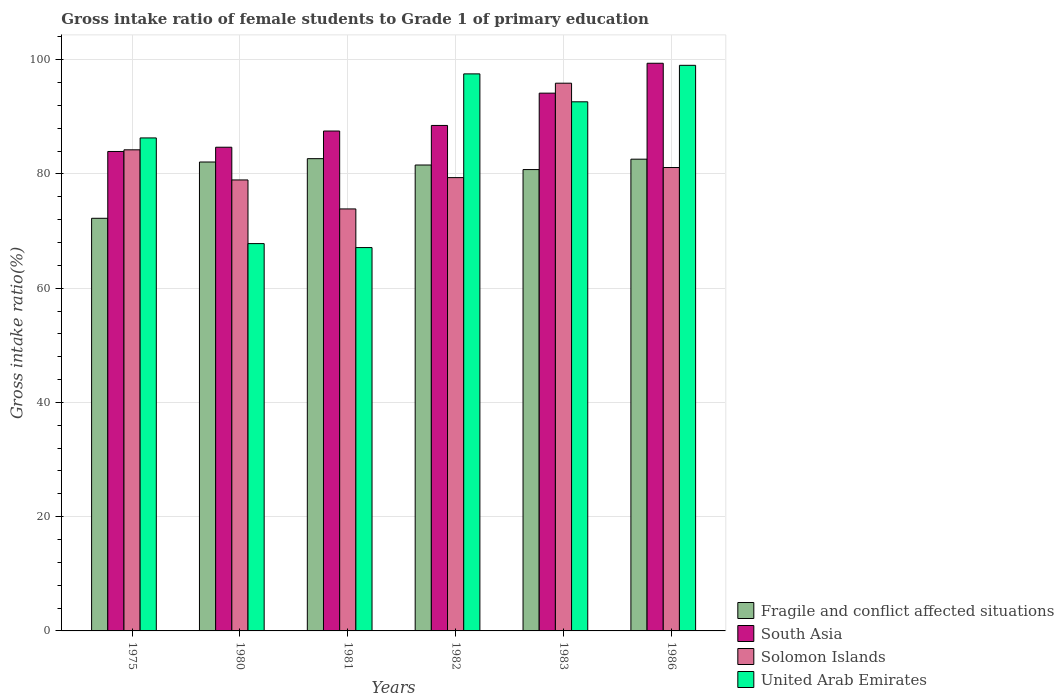How many different coloured bars are there?
Ensure brevity in your answer.  4. How many groups of bars are there?
Give a very brief answer. 6. Are the number of bars on each tick of the X-axis equal?
Ensure brevity in your answer.  Yes. How many bars are there on the 6th tick from the right?
Make the answer very short. 4. What is the gross intake ratio in Solomon Islands in 1986?
Your response must be concise. 81.12. Across all years, what is the maximum gross intake ratio in United Arab Emirates?
Your response must be concise. 99.01. Across all years, what is the minimum gross intake ratio in Fragile and conflict affected situations?
Make the answer very short. 72.23. In which year was the gross intake ratio in Fragile and conflict affected situations maximum?
Offer a terse response. 1981. In which year was the gross intake ratio in Fragile and conflict affected situations minimum?
Your answer should be very brief. 1975. What is the total gross intake ratio in Solomon Islands in the graph?
Make the answer very short. 493.39. What is the difference between the gross intake ratio in United Arab Emirates in 1975 and that in 1982?
Ensure brevity in your answer.  -11.21. What is the difference between the gross intake ratio in Solomon Islands in 1975 and the gross intake ratio in South Asia in 1980?
Provide a succinct answer. -0.45. What is the average gross intake ratio in Fragile and conflict affected situations per year?
Provide a short and direct response. 80.32. In the year 1981, what is the difference between the gross intake ratio in South Asia and gross intake ratio in Fragile and conflict affected situations?
Make the answer very short. 4.84. In how many years, is the gross intake ratio in South Asia greater than 72 %?
Your answer should be compact. 6. What is the ratio of the gross intake ratio in United Arab Emirates in 1982 to that in 1983?
Offer a terse response. 1.05. Is the gross intake ratio in Fragile and conflict affected situations in 1975 less than that in 1986?
Make the answer very short. Yes. What is the difference between the highest and the second highest gross intake ratio in Solomon Islands?
Offer a terse response. 11.66. What is the difference between the highest and the lowest gross intake ratio in Fragile and conflict affected situations?
Your response must be concise. 10.44. In how many years, is the gross intake ratio in South Asia greater than the average gross intake ratio in South Asia taken over all years?
Give a very brief answer. 2. What does the 2nd bar from the left in 1981 represents?
Keep it short and to the point. South Asia. What does the 2nd bar from the right in 1981 represents?
Provide a short and direct response. Solomon Islands. How many bars are there?
Your response must be concise. 24. How many years are there in the graph?
Provide a succinct answer. 6. What is the difference between two consecutive major ticks on the Y-axis?
Your answer should be very brief. 20. Are the values on the major ticks of Y-axis written in scientific E-notation?
Make the answer very short. No. Does the graph contain grids?
Your answer should be very brief. Yes. How many legend labels are there?
Ensure brevity in your answer.  4. How are the legend labels stacked?
Provide a short and direct response. Vertical. What is the title of the graph?
Your answer should be compact. Gross intake ratio of female students to Grade 1 of primary education. What is the label or title of the X-axis?
Your response must be concise. Years. What is the label or title of the Y-axis?
Your response must be concise. Gross intake ratio(%). What is the Gross intake ratio(%) of Fragile and conflict affected situations in 1975?
Your answer should be very brief. 72.23. What is the Gross intake ratio(%) in South Asia in 1975?
Ensure brevity in your answer.  83.93. What is the Gross intake ratio(%) in Solomon Islands in 1975?
Give a very brief answer. 84.22. What is the Gross intake ratio(%) of United Arab Emirates in 1975?
Offer a very short reply. 86.3. What is the Gross intake ratio(%) in Fragile and conflict affected situations in 1980?
Offer a terse response. 82.09. What is the Gross intake ratio(%) in South Asia in 1980?
Make the answer very short. 84.67. What is the Gross intake ratio(%) in Solomon Islands in 1980?
Ensure brevity in your answer.  78.95. What is the Gross intake ratio(%) in United Arab Emirates in 1980?
Provide a short and direct response. 67.8. What is the Gross intake ratio(%) of Fragile and conflict affected situations in 1981?
Ensure brevity in your answer.  82.67. What is the Gross intake ratio(%) in South Asia in 1981?
Ensure brevity in your answer.  87.51. What is the Gross intake ratio(%) in Solomon Islands in 1981?
Your answer should be compact. 73.87. What is the Gross intake ratio(%) of United Arab Emirates in 1981?
Ensure brevity in your answer.  67.11. What is the Gross intake ratio(%) of Fragile and conflict affected situations in 1982?
Your answer should be compact. 81.56. What is the Gross intake ratio(%) in South Asia in 1982?
Give a very brief answer. 88.49. What is the Gross intake ratio(%) of Solomon Islands in 1982?
Give a very brief answer. 79.35. What is the Gross intake ratio(%) of United Arab Emirates in 1982?
Offer a very short reply. 97.51. What is the Gross intake ratio(%) in Fragile and conflict affected situations in 1983?
Your response must be concise. 80.76. What is the Gross intake ratio(%) in South Asia in 1983?
Provide a short and direct response. 94.14. What is the Gross intake ratio(%) in Solomon Islands in 1983?
Make the answer very short. 95.88. What is the Gross intake ratio(%) of United Arab Emirates in 1983?
Your answer should be very brief. 92.62. What is the Gross intake ratio(%) in Fragile and conflict affected situations in 1986?
Offer a terse response. 82.58. What is the Gross intake ratio(%) in South Asia in 1986?
Offer a terse response. 99.37. What is the Gross intake ratio(%) in Solomon Islands in 1986?
Offer a very short reply. 81.12. What is the Gross intake ratio(%) in United Arab Emirates in 1986?
Your answer should be compact. 99.01. Across all years, what is the maximum Gross intake ratio(%) in Fragile and conflict affected situations?
Your answer should be compact. 82.67. Across all years, what is the maximum Gross intake ratio(%) of South Asia?
Your response must be concise. 99.37. Across all years, what is the maximum Gross intake ratio(%) in Solomon Islands?
Provide a succinct answer. 95.88. Across all years, what is the maximum Gross intake ratio(%) in United Arab Emirates?
Give a very brief answer. 99.01. Across all years, what is the minimum Gross intake ratio(%) of Fragile and conflict affected situations?
Your response must be concise. 72.23. Across all years, what is the minimum Gross intake ratio(%) in South Asia?
Provide a succinct answer. 83.93. Across all years, what is the minimum Gross intake ratio(%) of Solomon Islands?
Make the answer very short. 73.87. Across all years, what is the minimum Gross intake ratio(%) in United Arab Emirates?
Make the answer very short. 67.11. What is the total Gross intake ratio(%) of Fragile and conflict affected situations in the graph?
Offer a terse response. 481.89. What is the total Gross intake ratio(%) of South Asia in the graph?
Keep it short and to the point. 538.11. What is the total Gross intake ratio(%) in Solomon Islands in the graph?
Your answer should be compact. 493.39. What is the total Gross intake ratio(%) of United Arab Emirates in the graph?
Provide a short and direct response. 510.36. What is the difference between the Gross intake ratio(%) in Fragile and conflict affected situations in 1975 and that in 1980?
Offer a very short reply. -9.85. What is the difference between the Gross intake ratio(%) in South Asia in 1975 and that in 1980?
Provide a succinct answer. -0.74. What is the difference between the Gross intake ratio(%) of Solomon Islands in 1975 and that in 1980?
Provide a succinct answer. 5.27. What is the difference between the Gross intake ratio(%) in United Arab Emirates in 1975 and that in 1980?
Provide a short and direct response. 18.5. What is the difference between the Gross intake ratio(%) of Fragile and conflict affected situations in 1975 and that in 1981?
Provide a short and direct response. -10.44. What is the difference between the Gross intake ratio(%) of South Asia in 1975 and that in 1981?
Provide a short and direct response. -3.58. What is the difference between the Gross intake ratio(%) of Solomon Islands in 1975 and that in 1981?
Your answer should be very brief. 10.35. What is the difference between the Gross intake ratio(%) of United Arab Emirates in 1975 and that in 1981?
Your response must be concise. 19.19. What is the difference between the Gross intake ratio(%) in Fragile and conflict affected situations in 1975 and that in 1982?
Offer a terse response. -9.33. What is the difference between the Gross intake ratio(%) of South Asia in 1975 and that in 1982?
Provide a succinct answer. -4.56. What is the difference between the Gross intake ratio(%) in Solomon Islands in 1975 and that in 1982?
Keep it short and to the point. 4.87. What is the difference between the Gross intake ratio(%) in United Arab Emirates in 1975 and that in 1982?
Provide a short and direct response. -11.21. What is the difference between the Gross intake ratio(%) of Fragile and conflict affected situations in 1975 and that in 1983?
Offer a very short reply. -8.53. What is the difference between the Gross intake ratio(%) in South Asia in 1975 and that in 1983?
Make the answer very short. -10.21. What is the difference between the Gross intake ratio(%) of Solomon Islands in 1975 and that in 1983?
Give a very brief answer. -11.66. What is the difference between the Gross intake ratio(%) of United Arab Emirates in 1975 and that in 1983?
Give a very brief answer. -6.32. What is the difference between the Gross intake ratio(%) of Fragile and conflict affected situations in 1975 and that in 1986?
Ensure brevity in your answer.  -10.35. What is the difference between the Gross intake ratio(%) in South Asia in 1975 and that in 1986?
Make the answer very short. -15.44. What is the difference between the Gross intake ratio(%) of Solomon Islands in 1975 and that in 1986?
Your answer should be very brief. 3.1. What is the difference between the Gross intake ratio(%) of United Arab Emirates in 1975 and that in 1986?
Offer a terse response. -12.71. What is the difference between the Gross intake ratio(%) in Fragile and conflict affected situations in 1980 and that in 1981?
Your answer should be very brief. -0.58. What is the difference between the Gross intake ratio(%) of South Asia in 1980 and that in 1981?
Your response must be concise. -2.84. What is the difference between the Gross intake ratio(%) in Solomon Islands in 1980 and that in 1981?
Make the answer very short. 5.07. What is the difference between the Gross intake ratio(%) of United Arab Emirates in 1980 and that in 1981?
Your answer should be very brief. 0.69. What is the difference between the Gross intake ratio(%) of Fragile and conflict affected situations in 1980 and that in 1982?
Make the answer very short. 0.53. What is the difference between the Gross intake ratio(%) of South Asia in 1980 and that in 1982?
Keep it short and to the point. -3.81. What is the difference between the Gross intake ratio(%) of Solomon Islands in 1980 and that in 1982?
Offer a terse response. -0.41. What is the difference between the Gross intake ratio(%) of United Arab Emirates in 1980 and that in 1982?
Give a very brief answer. -29.71. What is the difference between the Gross intake ratio(%) in Fragile and conflict affected situations in 1980 and that in 1983?
Your answer should be very brief. 1.33. What is the difference between the Gross intake ratio(%) in South Asia in 1980 and that in 1983?
Offer a very short reply. -9.47. What is the difference between the Gross intake ratio(%) in Solomon Islands in 1980 and that in 1983?
Make the answer very short. -16.94. What is the difference between the Gross intake ratio(%) in United Arab Emirates in 1980 and that in 1983?
Give a very brief answer. -24.82. What is the difference between the Gross intake ratio(%) of Fragile and conflict affected situations in 1980 and that in 1986?
Keep it short and to the point. -0.49. What is the difference between the Gross intake ratio(%) in South Asia in 1980 and that in 1986?
Provide a succinct answer. -14.7. What is the difference between the Gross intake ratio(%) in Solomon Islands in 1980 and that in 1986?
Ensure brevity in your answer.  -2.17. What is the difference between the Gross intake ratio(%) of United Arab Emirates in 1980 and that in 1986?
Ensure brevity in your answer.  -31.21. What is the difference between the Gross intake ratio(%) in Fragile and conflict affected situations in 1981 and that in 1982?
Make the answer very short. 1.11. What is the difference between the Gross intake ratio(%) in South Asia in 1981 and that in 1982?
Offer a very short reply. -0.98. What is the difference between the Gross intake ratio(%) in Solomon Islands in 1981 and that in 1982?
Offer a very short reply. -5.48. What is the difference between the Gross intake ratio(%) in United Arab Emirates in 1981 and that in 1982?
Provide a short and direct response. -30.41. What is the difference between the Gross intake ratio(%) of Fragile and conflict affected situations in 1981 and that in 1983?
Offer a very short reply. 1.91. What is the difference between the Gross intake ratio(%) in South Asia in 1981 and that in 1983?
Your answer should be very brief. -6.63. What is the difference between the Gross intake ratio(%) in Solomon Islands in 1981 and that in 1983?
Your response must be concise. -22.01. What is the difference between the Gross intake ratio(%) of United Arab Emirates in 1981 and that in 1983?
Offer a very short reply. -25.52. What is the difference between the Gross intake ratio(%) in Fragile and conflict affected situations in 1981 and that in 1986?
Make the answer very short. 0.09. What is the difference between the Gross intake ratio(%) of South Asia in 1981 and that in 1986?
Keep it short and to the point. -11.86. What is the difference between the Gross intake ratio(%) of Solomon Islands in 1981 and that in 1986?
Your response must be concise. -7.25. What is the difference between the Gross intake ratio(%) in United Arab Emirates in 1981 and that in 1986?
Offer a very short reply. -31.9. What is the difference between the Gross intake ratio(%) in Fragile and conflict affected situations in 1982 and that in 1983?
Ensure brevity in your answer.  0.8. What is the difference between the Gross intake ratio(%) of South Asia in 1982 and that in 1983?
Ensure brevity in your answer.  -5.65. What is the difference between the Gross intake ratio(%) of Solomon Islands in 1982 and that in 1983?
Provide a succinct answer. -16.53. What is the difference between the Gross intake ratio(%) in United Arab Emirates in 1982 and that in 1983?
Ensure brevity in your answer.  4.89. What is the difference between the Gross intake ratio(%) in Fragile and conflict affected situations in 1982 and that in 1986?
Provide a succinct answer. -1.02. What is the difference between the Gross intake ratio(%) in South Asia in 1982 and that in 1986?
Provide a short and direct response. -10.89. What is the difference between the Gross intake ratio(%) in Solomon Islands in 1982 and that in 1986?
Offer a terse response. -1.77. What is the difference between the Gross intake ratio(%) in United Arab Emirates in 1982 and that in 1986?
Make the answer very short. -1.5. What is the difference between the Gross intake ratio(%) of Fragile and conflict affected situations in 1983 and that in 1986?
Keep it short and to the point. -1.82. What is the difference between the Gross intake ratio(%) in South Asia in 1983 and that in 1986?
Offer a very short reply. -5.23. What is the difference between the Gross intake ratio(%) in Solomon Islands in 1983 and that in 1986?
Make the answer very short. 14.76. What is the difference between the Gross intake ratio(%) in United Arab Emirates in 1983 and that in 1986?
Offer a terse response. -6.39. What is the difference between the Gross intake ratio(%) of Fragile and conflict affected situations in 1975 and the Gross intake ratio(%) of South Asia in 1980?
Offer a terse response. -12.44. What is the difference between the Gross intake ratio(%) in Fragile and conflict affected situations in 1975 and the Gross intake ratio(%) in Solomon Islands in 1980?
Your response must be concise. -6.71. What is the difference between the Gross intake ratio(%) in Fragile and conflict affected situations in 1975 and the Gross intake ratio(%) in United Arab Emirates in 1980?
Ensure brevity in your answer.  4.43. What is the difference between the Gross intake ratio(%) in South Asia in 1975 and the Gross intake ratio(%) in Solomon Islands in 1980?
Ensure brevity in your answer.  4.98. What is the difference between the Gross intake ratio(%) of South Asia in 1975 and the Gross intake ratio(%) of United Arab Emirates in 1980?
Ensure brevity in your answer.  16.13. What is the difference between the Gross intake ratio(%) in Solomon Islands in 1975 and the Gross intake ratio(%) in United Arab Emirates in 1980?
Ensure brevity in your answer.  16.42. What is the difference between the Gross intake ratio(%) of Fragile and conflict affected situations in 1975 and the Gross intake ratio(%) of South Asia in 1981?
Provide a short and direct response. -15.28. What is the difference between the Gross intake ratio(%) of Fragile and conflict affected situations in 1975 and the Gross intake ratio(%) of Solomon Islands in 1981?
Your response must be concise. -1.64. What is the difference between the Gross intake ratio(%) in Fragile and conflict affected situations in 1975 and the Gross intake ratio(%) in United Arab Emirates in 1981?
Your answer should be compact. 5.12. What is the difference between the Gross intake ratio(%) of South Asia in 1975 and the Gross intake ratio(%) of Solomon Islands in 1981?
Give a very brief answer. 10.06. What is the difference between the Gross intake ratio(%) in South Asia in 1975 and the Gross intake ratio(%) in United Arab Emirates in 1981?
Provide a short and direct response. 16.82. What is the difference between the Gross intake ratio(%) in Solomon Islands in 1975 and the Gross intake ratio(%) in United Arab Emirates in 1981?
Provide a short and direct response. 17.11. What is the difference between the Gross intake ratio(%) of Fragile and conflict affected situations in 1975 and the Gross intake ratio(%) of South Asia in 1982?
Make the answer very short. -16.25. What is the difference between the Gross intake ratio(%) in Fragile and conflict affected situations in 1975 and the Gross intake ratio(%) in Solomon Islands in 1982?
Your response must be concise. -7.12. What is the difference between the Gross intake ratio(%) of Fragile and conflict affected situations in 1975 and the Gross intake ratio(%) of United Arab Emirates in 1982?
Offer a terse response. -25.28. What is the difference between the Gross intake ratio(%) of South Asia in 1975 and the Gross intake ratio(%) of Solomon Islands in 1982?
Give a very brief answer. 4.58. What is the difference between the Gross intake ratio(%) of South Asia in 1975 and the Gross intake ratio(%) of United Arab Emirates in 1982?
Provide a short and direct response. -13.58. What is the difference between the Gross intake ratio(%) of Solomon Islands in 1975 and the Gross intake ratio(%) of United Arab Emirates in 1982?
Offer a terse response. -13.3. What is the difference between the Gross intake ratio(%) of Fragile and conflict affected situations in 1975 and the Gross intake ratio(%) of South Asia in 1983?
Provide a short and direct response. -21.91. What is the difference between the Gross intake ratio(%) of Fragile and conflict affected situations in 1975 and the Gross intake ratio(%) of Solomon Islands in 1983?
Your answer should be compact. -23.65. What is the difference between the Gross intake ratio(%) in Fragile and conflict affected situations in 1975 and the Gross intake ratio(%) in United Arab Emirates in 1983?
Make the answer very short. -20.39. What is the difference between the Gross intake ratio(%) of South Asia in 1975 and the Gross intake ratio(%) of Solomon Islands in 1983?
Give a very brief answer. -11.95. What is the difference between the Gross intake ratio(%) of South Asia in 1975 and the Gross intake ratio(%) of United Arab Emirates in 1983?
Keep it short and to the point. -8.69. What is the difference between the Gross intake ratio(%) of Solomon Islands in 1975 and the Gross intake ratio(%) of United Arab Emirates in 1983?
Offer a terse response. -8.41. What is the difference between the Gross intake ratio(%) in Fragile and conflict affected situations in 1975 and the Gross intake ratio(%) in South Asia in 1986?
Ensure brevity in your answer.  -27.14. What is the difference between the Gross intake ratio(%) in Fragile and conflict affected situations in 1975 and the Gross intake ratio(%) in Solomon Islands in 1986?
Offer a terse response. -8.89. What is the difference between the Gross intake ratio(%) of Fragile and conflict affected situations in 1975 and the Gross intake ratio(%) of United Arab Emirates in 1986?
Ensure brevity in your answer.  -26.78. What is the difference between the Gross intake ratio(%) in South Asia in 1975 and the Gross intake ratio(%) in Solomon Islands in 1986?
Offer a terse response. 2.81. What is the difference between the Gross intake ratio(%) in South Asia in 1975 and the Gross intake ratio(%) in United Arab Emirates in 1986?
Your answer should be compact. -15.08. What is the difference between the Gross intake ratio(%) in Solomon Islands in 1975 and the Gross intake ratio(%) in United Arab Emirates in 1986?
Your response must be concise. -14.79. What is the difference between the Gross intake ratio(%) in Fragile and conflict affected situations in 1980 and the Gross intake ratio(%) in South Asia in 1981?
Ensure brevity in your answer.  -5.42. What is the difference between the Gross intake ratio(%) in Fragile and conflict affected situations in 1980 and the Gross intake ratio(%) in Solomon Islands in 1981?
Offer a very short reply. 8.21. What is the difference between the Gross intake ratio(%) in Fragile and conflict affected situations in 1980 and the Gross intake ratio(%) in United Arab Emirates in 1981?
Keep it short and to the point. 14.98. What is the difference between the Gross intake ratio(%) in South Asia in 1980 and the Gross intake ratio(%) in Solomon Islands in 1981?
Provide a short and direct response. 10.8. What is the difference between the Gross intake ratio(%) of South Asia in 1980 and the Gross intake ratio(%) of United Arab Emirates in 1981?
Give a very brief answer. 17.56. What is the difference between the Gross intake ratio(%) in Solomon Islands in 1980 and the Gross intake ratio(%) in United Arab Emirates in 1981?
Your response must be concise. 11.84. What is the difference between the Gross intake ratio(%) in Fragile and conflict affected situations in 1980 and the Gross intake ratio(%) in Solomon Islands in 1982?
Give a very brief answer. 2.73. What is the difference between the Gross intake ratio(%) of Fragile and conflict affected situations in 1980 and the Gross intake ratio(%) of United Arab Emirates in 1982?
Provide a short and direct response. -15.43. What is the difference between the Gross intake ratio(%) in South Asia in 1980 and the Gross intake ratio(%) in Solomon Islands in 1982?
Offer a terse response. 5.32. What is the difference between the Gross intake ratio(%) of South Asia in 1980 and the Gross intake ratio(%) of United Arab Emirates in 1982?
Your answer should be very brief. -12.84. What is the difference between the Gross intake ratio(%) in Solomon Islands in 1980 and the Gross intake ratio(%) in United Arab Emirates in 1982?
Your answer should be compact. -18.57. What is the difference between the Gross intake ratio(%) in Fragile and conflict affected situations in 1980 and the Gross intake ratio(%) in South Asia in 1983?
Ensure brevity in your answer.  -12.05. What is the difference between the Gross intake ratio(%) of Fragile and conflict affected situations in 1980 and the Gross intake ratio(%) of Solomon Islands in 1983?
Offer a very short reply. -13.8. What is the difference between the Gross intake ratio(%) of Fragile and conflict affected situations in 1980 and the Gross intake ratio(%) of United Arab Emirates in 1983?
Your answer should be very brief. -10.54. What is the difference between the Gross intake ratio(%) of South Asia in 1980 and the Gross intake ratio(%) of Solomon Islands in 1983?
Keep it short and to the point. -11.21. What is the difference between the Gross intake ratio(%) of South Asia in 1980 and the Gross intake ratio(%) of United Arab Emirates in 1983?
Your answer should be very brief. -7.95. What is the difference between the Gross intake ratio(%) of Solomon Islands in 1980 and the Gross intake ratio(%) of United Arab Emirates in 1983?
Ensure brevity in your answer.  -13.68. What is the difference between the Gross intake ratio(%) of Fragile and conflict affected situations in 1980 and the Gross intake ratio(%) of South Asia in 1986?
Provide a short and direct response. -17.29. What is the difference between the Gross intake ratio(%) of Fragile and conflict affected situations in 1980 and the Gross intake ratio(%) of Solomon Islands in 1986?
Provide a succinct answer. 0.97. What is the difference between the Gross intake ratio(%) of Fragile and conflict affected situations in 1980 and the Gross intake ratio(%) of United Arab Emirates in 1986?
Offer a very short reply. -16.92. What is the difference between the Gross intake ratio(%) in South Asia in 1980 and the Gross intake ratio(%) in Solomon Islands in 1986?
Make the answer very short. 3.55. What is the difference between the Gross intake ratio(%) in South Asia in 1980 and the Gross intake ratio(%) in United Arab Emirates in 1986?
Give a very brief answer. -14.34. What is the difference between the Gross intake ratio(%) of Solomon Islands in 1980 and the Gross intake ratio(%) of United Arab Emirates in 1986?
Ensure brevity in your answer.  -20.06. What is the difference between the Gross intake ratio(%) of Fragile and conflict affected situations in 1981 and the Gross intake ratio(%) of South Asia in 1982?
Your answer should be compact. -5.82. What is the difference between the Gross intake ratio(%) in Fragile and conflict affected situations in 1981 and the Gross intake ratio(%) in Solomon Islands in 1982?
Provide a short and direct response. 3.32. What is the difference between the Gross intake ratio(%) in Fragile and conflict affected situations in 1981 and the Gross intake ratio(%) in United Arab Emirates in 1982?
Provide a succinct answer. -14.84. What is the difference between the Gross intake ratio(%) in South Asia in 1981 and the Gross intake ratio(%) in Solomon Islands in 1982?
Provide a succinct answer. 8.16. What is the difference between the Gross intake ratio(%) in South Asia in 1981 and the Gross intake ratio(%) in United Arab Emirates in 1982?
Ensure brevity in your answer.  -10. What is the difference between the Gross intake ratio(%) in Solomon Islands in 1981 and the Gross intake ratio(%) in United Arab Emirates in 1982?
Provide a succinct answer. -23.64. What is the difference between the Gross intake ratio(%) in Fragile and conflict affected situations in 1981 and the Gross intake ratio(%) in South Asia in 1983?
Offer a terse response. -11.47. What is the difference between the Gross intake ratio(%) of Fragile and conflict affected situations in 1981 and the Gross intake ratio(%) of Solomon Islands in 1983?
Make the answer very short. -13.21. What is the difference between the Gross intake ratio(%) of Fragile and conflict affected situations in 1981 and the Gross intake ratio(%) of United Arab Emirates in 1983?
Offer a very short reply. -9.95. What is the difference between the Gross intake ratio(%) in South Asia in 1981 and the Gross intake ratio(%) in Solomon Islands in 1983?
Provide a short and direct response. -8.37. What is the difference between the Gross intake ratio(%) in South Asia in 1981 and the Gross intake ratio(%) in United Arab Emirates in 1983?
Offer a very short reply. -5.12. What is the difference between the Gross intake ratio(%) of Solomon Islands in 1981 and the Gross intake ratio(%) of United Arab Emirates in 1983?
Offer a very short reply. -18.75. What is the difference between the Gross intake ratio(%) in Fragile and conflict affected situations in 1981 and the Gross intake ratio(%) in South Asia in 1986?
Your response must be concise. -16.7. What is the difference between the Gross intake ratio(%) of Fragile and conflict affected situations in 1981 and the Gross intake ratio(%) of Solomon Islands in 1986?
Your answer should be compact. 1.55. What is the difference between the Gross intake ratio(%) of Fragile and conflict affected situations in 1981 and the Gross intake ratio(%) of United Arab Emirates in 1986?
Your answer should be very brief. -16.34. What is the difference between the Gross intake ratio(%) in South Asia in 1981 and the Gross intake ratio(%) in Solomon Islands in 1986?
Offer a terse response. 6.39. What is the difference between the Gross intake ratio(%) of South Asia in 1981 and the Gross intake ratio(%) of United Arab Emirates in 1986?
Offer a terse response. -11.5. What is the difference between the Gross intake ratio(%) in Solomon Islands in 1981 and the Gross intake ratio(%) in United Arab Emirates in 1986?
Give a very brief answer. -25.14. What is the difference between the Gross intake ratio(%) of Fragile and conflict affected situations in 1982 and the Gross intake ratio(%) of South Asia in 1983?
Keep it short and to the point. -12.58. What is the difference between the Gross intake ratio(%) in Fragile and conflict affected situations in 1982 and the Gross intake ratio(%) in Solomon Islands in 1983?
Provide a short and direct response. -14.32. What is the difference between the Gross intake ratio(%) in Fragile and conflict affected situations in 1982 and the Gross intake ratio(%) in United Arab Emirates in 1983?
Offer a terse response. -11.06. What is the difference between the Gross intake ratio(%) in South Asia in 1982 and the Gross intake ratio(%) in Solomon Islands in 1983?
Offer a very short reply. -7.4. What is the difference between the Gross intake ratio(%) in South Asia in 1982 and the Gross intake ratio(%) in United Arab Emirates in 1983?
Provide a succinct answer. -4.14. What is the difference between the Gross intake ratio(%) of Solomon Islands in 1982 and the Gross intake ratio(%) of United Arab Emirates in 1983?
Provide a short and direct response. -13.27. What is the difference between the Gross intake ratio(%) in Fragile and conflict affected situations in 1982 and the Gross intake ratio(%) in South Asia in 1986?
Offer a terse response. -17.81. What is the difference between the Gross intake ratio(%) in Fragile and conflict affected situations in 1982 and the Gross intake ratio(%) in Solomon Islands in 1986?
Provide a succinct answer. 0.44. What is the difference between the Gross intake ratio(%) in Fragile and conflict affected situations in 1982 and the Gross intake ratio(%) in United Arab Emirates in 1986?
Your answer should be compact. -17.45. What is the difference between the Gross intake ratio(%) of South Asia in 1982 and the Gross intake ratio(%) of Solomon Islands in 1986?
Provide a succinct answer. 7.37. What is the difference between the Gross intake ratio(%) in South Asia in 1982 and the Gross intake ratio(%) in United Arab Emirates in 1986?
Offer a very short reply. -10.52. What is the difference between the Gross intake ratio(%) of Solomon Islands in 1982 and the Gross intake ratio(%) of United Arab Emirates in 1986?
Your answer should be compact. -19.66. What is the difference between the Gross intake ratio(%) of Fragile and conflict affected situations in 1983 and the Gross intake ratio(%) of South Asia in 1986?
Your answer should be compact. -18.61. What is the difference between the Gross intake ratio(%) of Fragile and conflict affected situations in 1983 and the Gross intake ratio(%) of Solomon Islands in 1986?
Give a very brief answer. -0.36. What is the difference between the Gross intake ratio(%) in Fragile and conflict affected situations in 1983 and the Gross intake ratio(%) in United Arab Emirates in 1986?
Your answer should be compact. -18.25. What is the difference between the Gross intake ratio(%) of South Asia in 1983 and the Gross intake ratio(%) of Solomon Islands in 1986?
Your answer should be very brief. 13.02. What is the difference between the Gross intake ratio(%) in South Asia in 1983 and the Gross intake ratio(%) in United Arab Emirates in 1986?
Offer a very short reply. -4.87. What is the difference between the Gross intake ratio(%) in Solomon Islands in 1983 and the Gross intake ratio(%) in United Arab Emirates in 1986?
Offer a terse response. -3.13. What is the average Gross intake ratio(%) in Fragile and conflict affected situations per year?
Your answer should be very brief. 80.32. What is the average Gross intake ratio(%) in South Asia per year?
Offer a terse response. 89.68. What is the average Gross intake ratio(%) in Solomon Islands per year?
Your answer should be compact. 82.23. What is the average Gross intake ratio(%) in United Arab Emirates per year?
Make the answer very short. 85.06. In the year 1975, what is the difference between the Gross intake ratio(%) in Fragile and conflict affected situations and Gross intake ratio(%) in South Asia?
Make the answer very short. -11.7. In the year 1975, what is the difference between the Gross intake ratio(%) of Fragile and conflict affected situations and Gross intake ratio(%) of Solomon Islands?
Give a very brief answer. -11.98. In the year 1975, what is the difference between the Gross intake ratio(%) in Fragile and conflict affected situations and Gross intake ratio(%) in United Arab Emirates?
Offer a terse response. -14.07. In the year 1975, what is the difference between the Gross intake ratio(%) of South Asia and Gross intake ratio(%) of Solomon Islands?
Keep it short and to the point. -0.29. In the year 1975, what is the difference between the Gross intake ratio(%) of South Asia and Gross intake ratio(%) of United Arab Emirates?
Make the answer very short. -2.37. In the year 1975, what is the difference between the Gross intake ratio(%) in Solomon Islands and Gross intake ratio(%) in United Arab Emirates?
Your answer should be compact. -2.08. In the year 1980, what is the difference between the Gross intake ratio(%) of Fragile and conflict affected situations and Gross intake ratio(%) of South Asia?
Make the answer very short. -2.59. In the year 1980, what is the difference between the Gross intake ratio(%) of Fragile and conflict affected situations and Gross intake ratio(%) of Solomon Islands?
Ensure brevity in your answer.  3.14. In the year 1980, what is the difference between the Gross intake ratio(%) of Fragile and conflict affected situations and Gross intake ratio(%) of United Arab Emirates?
Your response must be concise. 14.29. In the year 1980, what is the difference between the Gross intake ratio(%) in South Asia and Gross intake ratio(%) in Solomon Islands?
Keep it short and to the point. 5.73. In the year 1980, what is the difference between the Gross intake ratio(%) in South Asia and Gross intake ratio(%) in United Arab Emirates?
Keep it short and to the point. 16.87. In the year 1980, what is the difference between the Gross intake ratio(%) of Solomon Islands and Gross intake ratio(%) of United Arab Emirates?
Make the answer very short. 11.14. In the year 1981, what is the difference between the Gross intake ratio(%) of Fragile and conflict affected situations and Gross intake ratio(%) of South Asia?
Your answer should be compact. -4.84. In the year 1981, what is the difference between the Gross intake ratio(%) of Fragile and conflict affected situations and Gross intake ratio(%) of Solomon Islands?
Offer a terse response. 8.8. In the year 1981, what is the difference between the Gross intake ratio(%) of Fragile and conflict affected situations and Gross intake ratio(%) of United Arab Emirates?
Your answer should be very brief. 15.56. In the year 1981, what is the difference between the Gross intake ratio(%) of South Asia and Gross intake ratio(%) of Solomon Islands?
Offer a very short reply. 13.64. In the year 1981, what is the difference between the Gross intake ratio(%) in South Asia and Gross intake ratio(%) in United Arab Emirates?
Make the answer very short. 20.4. In the year 1981, what is the difference between the Gross intake ratio(%) of Solomon Islands and Gross intake ratio(%) of United Arab Emirates?
Your answer should be compact. 6.76. In the year 1982, what is the difference between the Gross intake ratio(%) in Fragile and conflict affected situations and Gross intake ratio(%) in South Asia?
Offer a terse response. -6.93. In the year 1982, what is the difference between the Gross intake ratio(%) of Fragile and conflict affected situations and Gross intake ratio(%) of Solomon Islands?
Your response must be concise. 2.21. In the year 1982, what is the difference between the Gross intake ratio(%) of Fragile and conflict affected situations and Gross intake ratio(%) of United Arab Emirates?
Give a very brief answer. -15.95. In the year 1982, what is the difference between the Gross intake ratio(%) in South Asia and Gross intake ratio(%) in Solomon Islands?
Ensure brevity in your answer.  9.13. In the year 1982, what is the difference between the Gross intake ratio(%) of South Asia and Gross intake ratio(%) of United Arab Emirates?
Offer a very short reply. -9.03. In the year 1982, what is the difference between the Gross intake ratio(%) of Solomon Islands and Gross intake ratio(%) of United Arab Emirates?
Provide a succinct answer. -18.16. In the year 1983, what is the difference between the Gross intake ratio(%) in Fragile and conflict affected situations and Gross intake ratio(%) in South Asia?
Keep it short and to the point. -13.38. In the year 1983, what is the difference between the Gross intake ratio(%) of Fragile and conflict affected situations and Gross intake ratio(%) of Solomon Islands?
Your answer should be very brief. -15.12. In the year 1983, what is the difference between the Gross intake ratio(%) of Fragile and conflict affected situations and Gross intake ratio(%) of United Arab Emirates?
Your answer should be compact. -11.86. In the year 1983, what is the difference between the Gross intake ratio(%) in South Asia and Gross intake ratio(%) in Solomon Islands?
Your answer should be compact. -1.74. In the year 1983, what is the difference between the Gross intake ratio(%) of South Asia and Gross intake ratio(%) of United Arab Emirates?
Your response must be concise. 1.51. In the year 1983, what is the difference between the Gross intake ratio(%) of Solomon Islands and Gross intake ratio(%) of United Arab Emirates?
Make the answer very short. 3.26. In the year 1986, what is the difference between the Gross intake ratio(%) of Fragile and conflict affected situations and Gross intake ratio(%) of South Asia?
Your response must be concise. -16.79. In the year 1986, what is the difference between the Gross intake ratio(%) of Fragile and conflict affected situations and Gross intake ratio(%) of Solomon Islands?
Your answer should be compact. 1.46. In the year 1986, what is the difference between the Gross intake ratio(%) of Fragile and conflict affected situations and Gross intake ratio(%) of United Arab Emirates?
Keep it short and to the point. -16.43. In the year 1986, what is the difference between the Gross intake ratio(%) of South Asia and Gross intake ratio(%) of Solomon Islands?
Your answer should be compact. 18.25. In the year 1986, what is the difference between the Gross intake ratio(%) of South Asia and Gross intake ratio(%) of United Arab Emirates?
Provide a short and direct response. 0.36. In the year 1986, what is the difference between the Gross intake ratio(%) in Solomon Islands and Gross intake ratio(%) in United Arab Emirates?
Keep it short and to the point. -17.89. What is the ratio of the Gross intake ratio(%) of Solomon Islands in 1975 to that in 1980?
Your answer should be very brief. 1.07. What is the ratio of the Gross intake ratio(%) of United Arab Emirates in 1975 to that in 1980?
Ensure brevity in your answer.  1.27. What is the ratio of the Gross intake ratio(%) in Fragile and conflict affected situations in 1975 to that in 1981?
Ensure brevity in your answer.  0.87. What is the ratio of the Gross intake ratio(%) in South Asia in 1975 to that in 1981?
Give a very brief answer. 0.96. What is the ratio of the Gross intake ratio(%) in Solomon Islands in 1975 to that in 1981?
Keep it short and to the point. 1.14. What is the ratio of the Gross intake ratio(%) in United Arab Emirates in 1975 to that in 1981?
Keep it short and to the point. 1.29. What is the ratio of the Gross intake ratio(%) of Fragile and conflict affected situations in 1975 to that in 1982?
Ensure brevity in your answer.  0.89. What is the ratio of the Gross intake ratio(%) of South Asia in 1975 to that in 1982?
Offer a terse response. 0.95. What is the ratio of the Gross intake ratio(%) of Solomon Islands in 1975 to that in 1982?
Provide a succinct answer. 1.06. What is the ratio of the Gross intake ratio(%) in United Arab Emirates in 1975 to that in 1982?
Make the answer very short. 0.89. What is the ratio of the Gross intake ratio(%) in Fragile and conflict affected situations in 1975 to that in 1983?
Make the answer very short. 0.89. What is the ratio of the Gross intake ratio(%) of South Asia in 1975 to that in 1983?
Make the answer very short. 0.89. What is the ratio of the Gross intake ratio(%) of Solomon Islands in 1975 to that in 1983?
Your answer should be compact. 0.88. What is the ratio of the Gross intake ratio(%) of United Arab Emirates in 1975 to that in 1983?
Offer a terse response. 0.93. What is the ratio of the Gross intake ratio(%) in Fragile and conflict affected situations in 1975 to that in 1986?
Give a very brief answer. 0.87. What is the ratio of the Gross intake ratio(%) in South Asia in 1975 to that in 1986?
Keep it short and to the point. 0.84. What is the ratio of the Gross intake ratio(%) of Solomon Islands in 1975 to that in 1986?
Provide a succinct answer. 1.04. What is the ratio of the Gross intake ratio(%) in United Arab Emirates in 1975 to that in 1986?
Provide a succinct answer. 0.87. What is the ratio of the Gross intake ratio(%) of South Asia in 1980 to that in 1981?
Your response must be concise. 0.97. What is the ratio of the Gross intake ratio(%) of Solomon Islands in 1980 to that in 1981?
Offer a terse response. 1.07. What is the ratio of the Gross intake ratio(%) of United Arab Emirates in 1980 to that in 1981?
Ensure brevity in your answer.  1.01. What is the ratio of the Gross intake ratio(%) in South Asia in 1980 to that in 1982?
Your response must be concise. 0.96. What is the ratio of the Gross intake ratio(%) in United Arab Emirates in 1980 to that in 1982?
Provide a short and direct response. 0.7. What is the ratio of the Gross intake ratio(%) of Fragile and conflict affected situations in 1980 to that in 1983?
Your answer should be very brief. 1.02. What is the ratio of the Gross intake ratio(%) in South Asia in 1980 to that in 1983?
Provide a short and direct response. 0.9. What is the ratio of the Gross intake ratio(%) of Solomon Islands in 1980 to that in 1983?
Ensure brevity in your answer.  0.82. What is the ratio of the Gross intake ratio(%) in United Arab Emirates in 1980 to that in 1983?
Offer a very short reply. 0.73. What is the ratio of the Gross intake ratio(%) of Fragile and conflict affected situations in 1980 to that in 1986?
Ensure brevity in your answer.  0.99. What is the ratio of the Gross intake ratio(%) in South Asia in 1980 to that in 1986?
Your answer should be very brief. 0.85. What is the ratio of the Gross intake ratio(%) in Solomon Islands in 1980 to that in 1986?
Offer a very short reply. 0.97. What is the ratio of the Gross intake ratio(%) in United Arab Emirates in 1980 to that in 1986?
Your response must be concise. 0.68. What is the ratio of the Gross intake ratio(%) of Fragile and conflict affected situations in 1981 to that in 1982?
Provide a short and direct response. 1.01. What is the ratio of the Gross intake ratio(%) of South Asia in 1981 to that in 1982?
Your answer should be compact. 0.99. What is the ratio of the Gross intake ratio(%) in Solomon Islands in 1981 to that in 1982?
Your answer should be very brief. 0.93. What is the ratio of the Gross intake ratio(%) of United Arab Emirates in 1981 to that in 1982?
Offer a terse response. 0.69. What is the ratio of the Gross intake ratio(%) in Fragile and conflict affected situations in 1981 to that in 1983?
Make the answer very short. 1.02. What is the ratio of the Gross intake ratio(%) of South Asia in 1981 to that in 1983?
Offer a very short reply. 0.93. What is the ratio of the Gross intake ratio(%) in Solomon Islands in 1981 to that in 1983?
Offer a terse response. 0.77. What is the ratio of the Gross intake ratio(%) in United Arab Emirates in 1981 to that in 1983?
Offer a very short reply. 0.72. What is the ratio of the Gross intake ratio(%) in South Asia in 1981 to that in 1986?
Your answer should be very brief. 0.88. What is the ratio of the Gross intake ratio(%) in Solomon Islands in 1981 to that in 1986?
Your answer should be compact. 0.91. What is the ratio of the Gross intake ratio(%) of United Arab Emirates in 1981 to that in 1986?
Your response must be concise. 0.68. What is the ratio of the Gross intake ratio(%) of Fragile and conflict affected situations in 1982 to that in 1983?
Offer a terse response. 1.01. What is the ratio of the Gross intake ratio(%) in South Asia in 1982 to that in 1983?
Your answer should be compact. 0.94. What is the ratio of the Gross intake ratio(%) of Solomon Islands in 1982 to that in 1983?
Make the answer very short. 0.83. What is the ratio of the Gross intake ratio(%) in United Arab Emirates in 1982 to that in 1983?
Offer a very short reply. 1.05. What is the ratio of the Gross intake ratio(%) in Fragile and conflict affected situations in 1982 to that in 1986?
Give a very brief answer. 0.99. What is the ratio of the Gross intake ratio(%) in South Asia in 1982 to that in 1986?
Offer a very short reply. 0.89. What is the ratio of the Gross intake ratio(%) of Solomon Islands in 1982 to that in 1986?
Give a very brief answer. 0.98. What is the ratio of the Gross intake ratio(%) in United Arab Emirates in 1982 to that in 1986?
Provide a short and direct response. 0.98. What is the ratio of the Gross intake ratio(%) of South Asia in 1983 to that in 1986?
Your answer should be very brief. 0.95. What is the ratio of the Gross intake ratio(%) of Solomon Islands in 1983 to that in 1986?
Make the answer very short. 1.18. What is the ratio of the Gross intake ratio(%) in United Arab Emirates in 1983 to that in 1986?
Keep it short and to the point. 0.94. What is the difference between the highest and the second highest Gross intake ratio(%) in Fragile and conflict affected situations?
Your response must be concise. 0.09. What is the difference between the highest and the second highest Gross intake ratio(%) of South Asia?
Your answer should be compact. 5.23. What is the difference between the highest and the second highest Gross intake ratio(%) of Solomon Islands?
Offer a terse response. 11.66. What is the difference between the highest and the second highest Gross intake ratio(%) of United Arab Emirates?
Give a very brief answer. 1.5. What is the difference between the highest and the lowest Gross intake ratio(%) of Fragile and conflict affected situations?
Keep it short and to the point. 10.44. What is the difference between the highest and the lowest Gross intake ratio(%) in South Asia?
Ensure brevity in your answer.  15.44. What is the difference between the highest and the lowest Gross intake ratio(%) of Solomon Islands?
Your answer should be compact. 22.01. What is the difference between the highest and the lowest Gross intake ratio(%) in United Arab Emirates?
Provide a short and direct response. 31.9. 